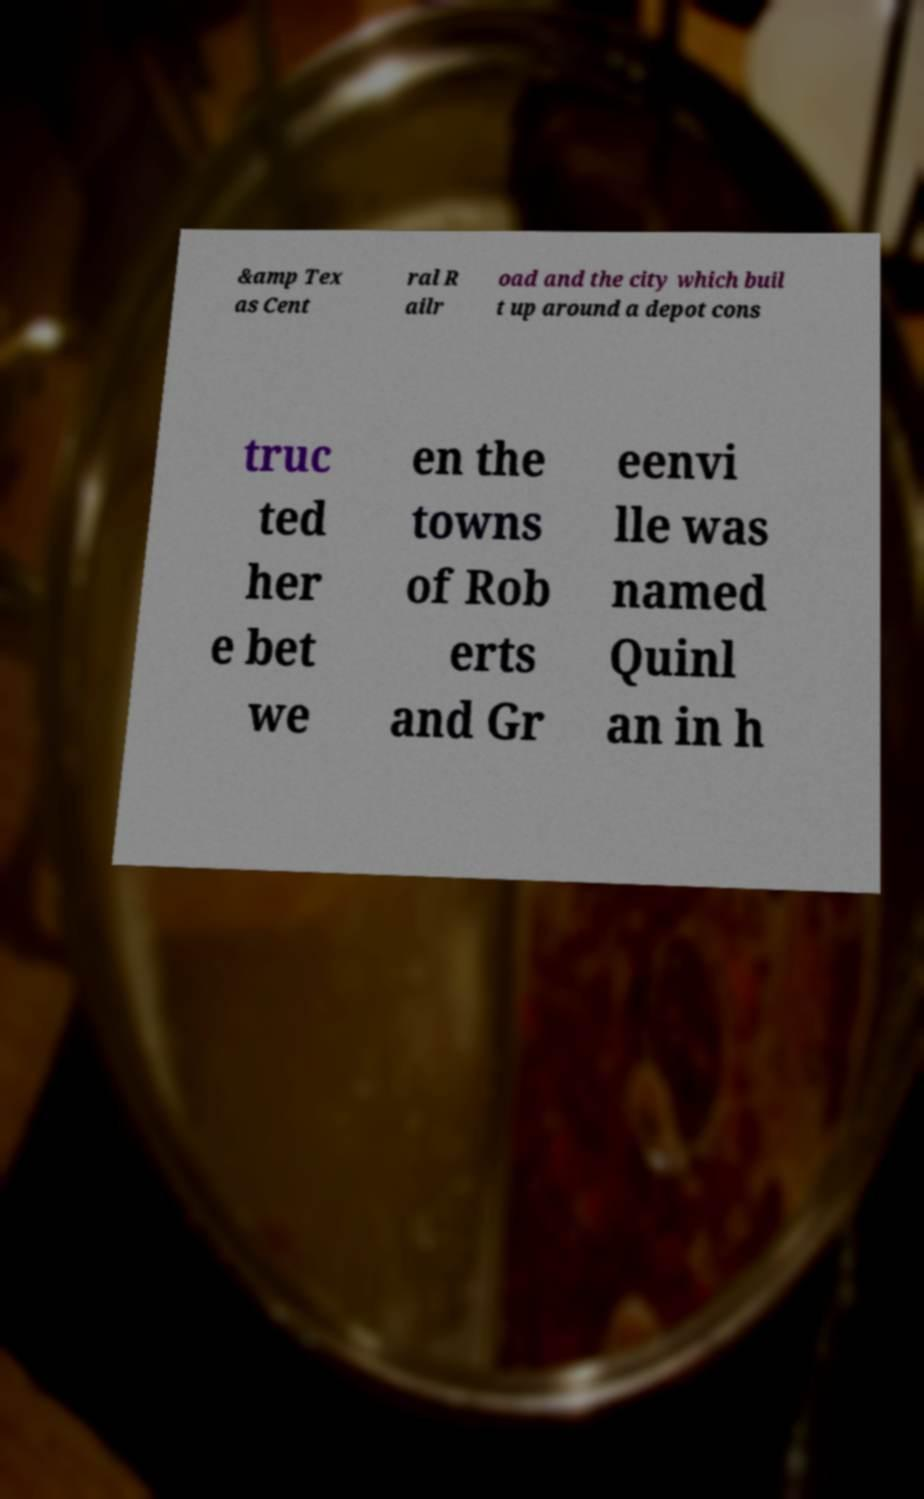Please identify and transcribe the text found in this image. &amp Tex as Cent ral R ailr oad and the city which buil t up around a depot cons truc ted her e bet we en the towns of Rob erts and Gr eenvi lle was named Quinl an in h 